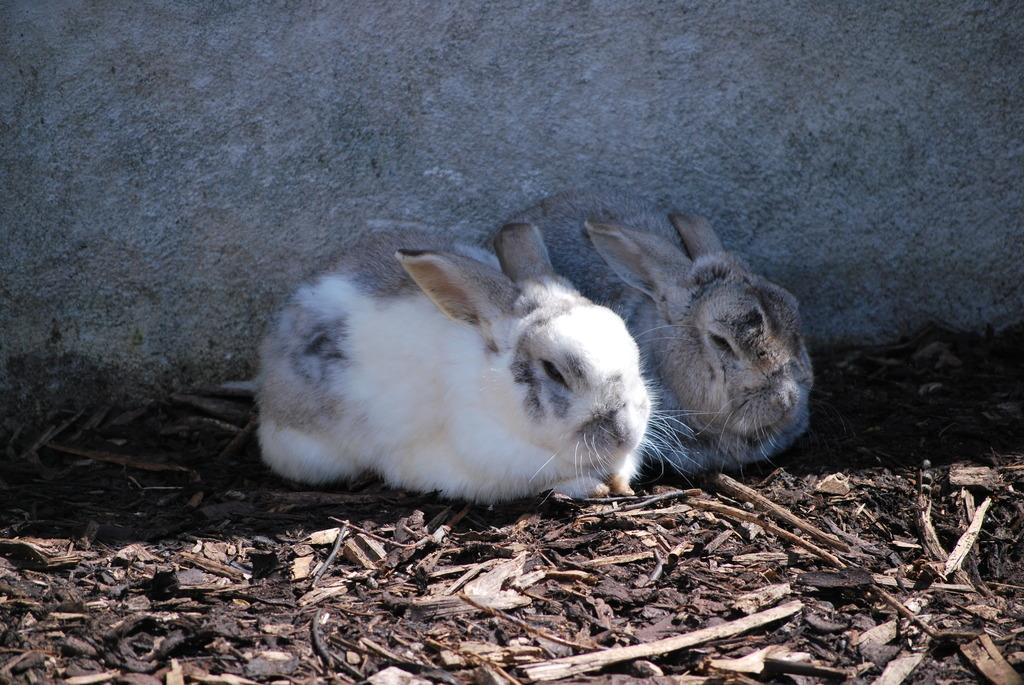What animals are present in the image? There are rabbits in the image. What are the rabbits sitting on? The rabbits are sitting on wooden sticks. What can be seen in the background of the image? There is a wall in the background of the image. What type of bomb can be seen in the image? There is no bomb present in the image; it features rabbits sitting on wooden sticks with a wall in the background. 